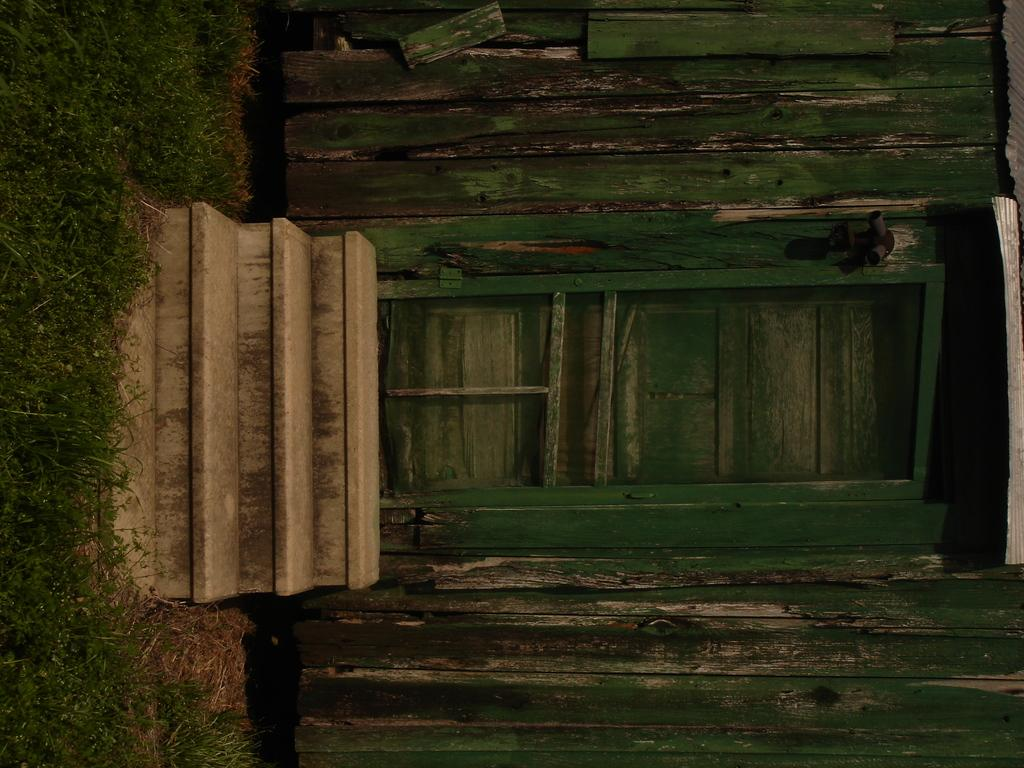What type of house is shown in the picture? There is a wooden house in the picture. Where is the main entrance to the house located? There is a door in the center of the house. Are there any interior features visible in the picture? Yes, there are stairs in the house. What can be seen on the left side of the house? There is green grass on the left side of the house. What type of scent can be detected coming from the house in the image? There is no information about the scent in the image, as it only shows the exterior of the house. --- Facts: 1. There is a person sitting on a chair in the image. 2. The person is holding a book. 3. There is a table next to the chair. 4. There is a lamp on the table. 5. The background of the image is a bookshelf. Absurd Topics: ocean, parrot, bicycle Conversation: What is the person in the image doing? The person is sitting on a chair in the image. What object is the person holding? The person is holding a book. What is located next to the chair? There is a table next to the chair. What is on the table? There is a lamp on the table. What can be seen in the background of the image? The background of the image is a bookshelf. Reasoning: Let's think step by step in order to produce the conversation. We start by identifying the main subject in the image, which is the person sitting on a chair. Then, we describe the object the person is holding, which is a book. Next, we mention the table and the lamp, which are both located near the chair. Finally, we describe the background of the image, which is a bookshelf. Absurd Question/Answer: Can you see any ocean or parrot in the image? No, there is no ocean or parrot present in the image. Is there a bicycle visible in the image? No, there is no bicycle visible in the image. 